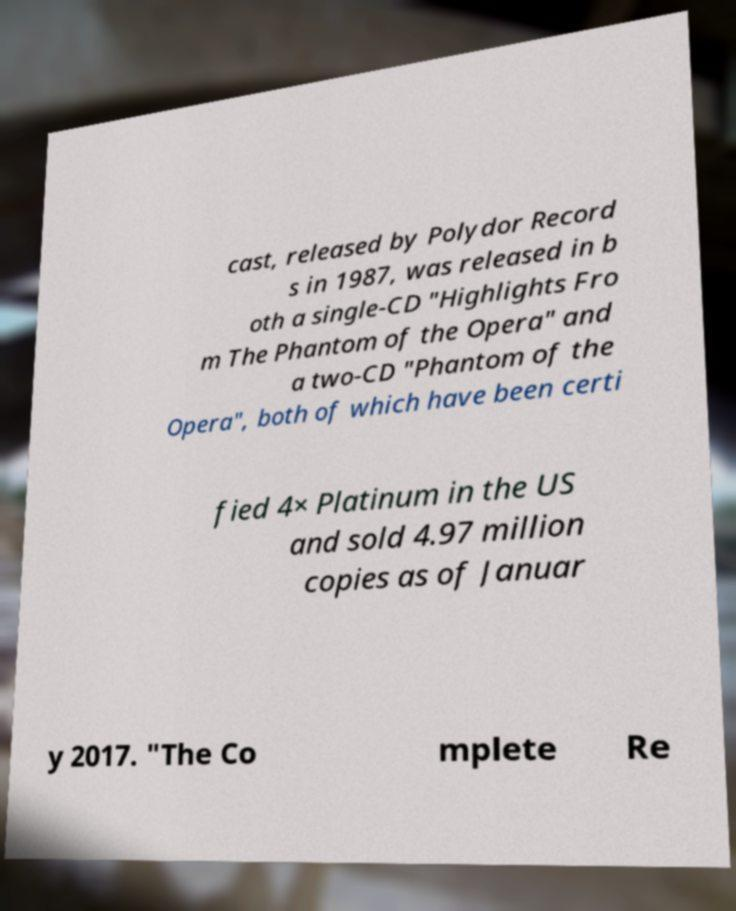Could you assist in decoding the text presented in this image and type it out clearly? cast, released by Polydor Record s in 1987, was released in b oth a single-CD "Highlights Fro m The Phantom of the Opera" and a two-CD "Phantom of the Opera", both of which have been certi fied 4× Platinum in the US and sold 4.97 million copies as of Januar y 2017. "The Co mplete Re 